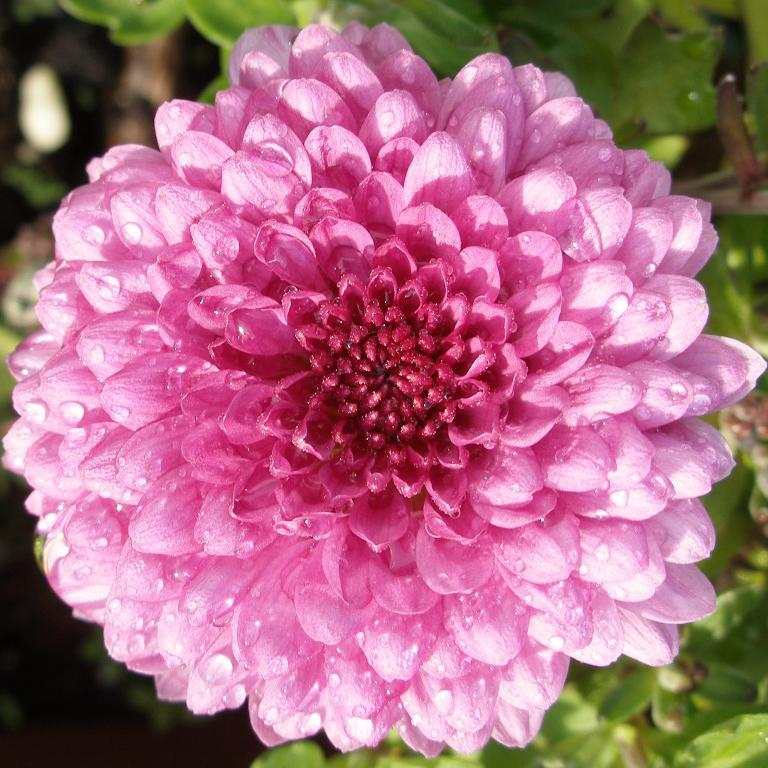What type of plant is visible in the image? There is a flower and leaves in the image, which suggests that there is a plant present. Can you describe the flower in the image? Unfortunately, the facts provided do not give enough detail to describe the flower. What else is present in the image besides the flower and leaves? The facts provided only mention the flower, leaves, and the presence of a plant. What type of train can be seen passing by the flower in the image? There is no train present in the image; it only features a flower, leaves, and a plant. How does the robin interact with the flower in the image? There is no robin present in the image; it only features a flower, leaves, and a plant. 